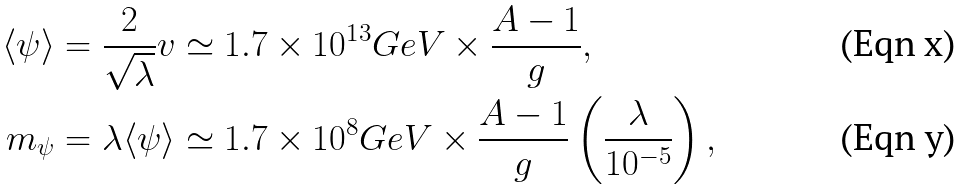<formula> <loc_0><loc_0><loc_500><loc_500>\langle \psi \rangle & = \frac { 2 } { \sqrt { \lambda } } v \simeq 1 . 7 \times 1 0 ^ { 1 3 } G e V \times \frac { A - 1 } { g } , \\ m _ { \psi } & = \lambda \langle \psi \rangle \simeq 1 . 7 \times 1 0 ^ { 8 } G e V \times \frac { A - 1 } { g } \left ( \frac { \lambda } { 1 0 ^ { - 5 } } \right ) ,</formula> 